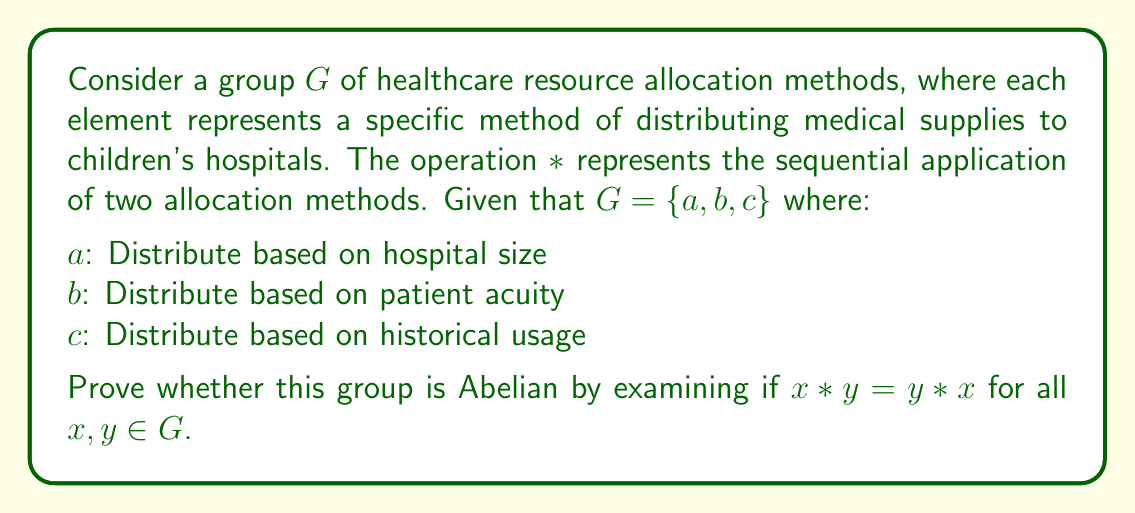Help me with this question. To prove whether the group $G$ is Abelian, we need to check if the operation $*$ is commutative for all pairs of elements in $G$. We will examine each possible pair:

1. $a * b$ vs $b * a$:
   $a * b$ represents first distributing based on hospital size, then adjusting based on patient acuity.
   $b * a$ represents first distributing based on patient acuity, then adjusting based on hospital size.
   These two methods may yield different results, as the initial distribution affects the subsequent adjustment.

2. $a * c$ vs $c * a$:
   $a * c$ represents distributing based on hospital size, then adjusting based on historical usage.
   $c * a$ represents distributing based on historical usage, then adjusting based on hospital size.
   Again, these methods may produce different outcomes.

3. $b * c$ vs $c * b$:
   $b * c$ represents distributing based on patient acuity, then adjusting based on historical usage.
   $c * b$ represents distributing based on historical usage, then adjusting based on patient acuity.
   These methods may also lead to different final distributions.

Since we have found at least one pair (and potentially all pairs) where $x * y \neq y * x$, we can conclude that the operation $*$ is not commutative for all elements in $G$.
Answer: The group $G$ of healthcare resource allocation methods is not Abelian, as the operation $*$ is not commutative for all pairs of elements in $G$. 